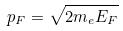<formula> <loc_0><loc_0><loc_500><loc_500>p _ { F } = \sqrt { 2 m _ { e } E _ { F } }</formula> 